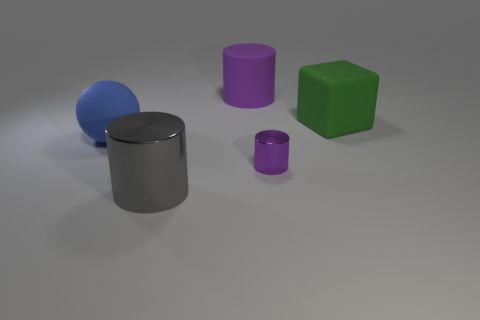Is there any other thing that has the same size as the purple metal cylinder?
Keep it short and to the point. No. The other rubber cylinder that is the same color as the small cylinder is what size?
Make the answer very short. Large. There is another object that is the same color as the tiny object; what shape is it?
Ensure brevity in your answer.  Cylinder. What number of purple cylinders have the same size as the blue rubber object?
Give a very brief answer. 1. Is there a gray object on the right side of the purple thing in front of the large purple object?
Offer a terse response. No. How many objects are either large gray matte balls or large purple cylinders?
Keep it short and to the point. 1. There is a large rubber thing that is to the left of the object that is in front of the purple cylinder in front of the large ball; what color is it?
Keep it short and to the point. Blue. Is there any other thing of the same color as the rubber cylinder?
Provide a short and direct response. Yes. Is the blue rubber sphere the same size as the purple metal cylinder?
Your answer should be very brief. No. How many objects are either big things that are right of the big shiny cylinder or big things to the right of the purple matte object?
Your answer should be very brief. 2. 